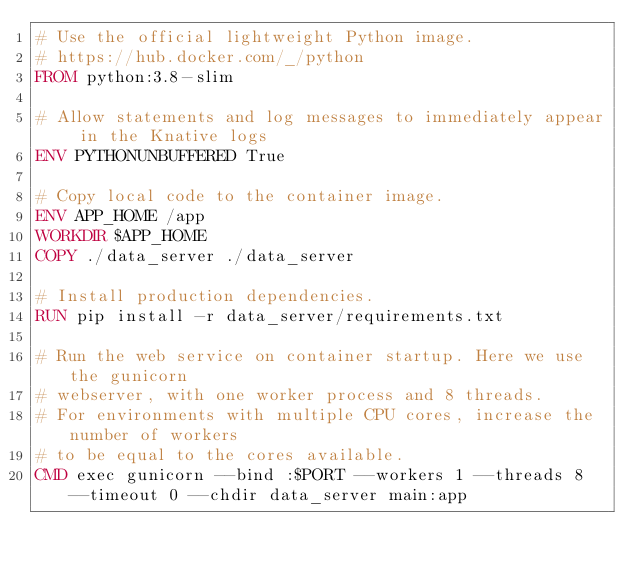<code> <loc_0><loc_0><loc_500><loc_500><_Dockerfile_># Use the official lightweight Python image.
# https://hub.docker.com/_/python
FROM python:3.8-slim

# Allow statements and log messages to immediately appear in the Knative logs
ENV PYTHONUNBUFFERED True

# Copy local code to the container image.
ENV APP_HOME /app
WORKDIR $APP_HOME
COPY ./data_server ./data_server

# Install production dependencies.
RUN pip install -r data_server/requirements.txt

# Run the web service on container startup. Here we use the gunicorn
# webserver, with one worker process and 8 threads.
# For environments with multiple CPU cores, increase the number of workers
# to be equal to the cores available.
CMD exec gunicorn --bind :$PORT --workers 1 --threads 8 --timeout 0 --chdir data_server main:app</code> 